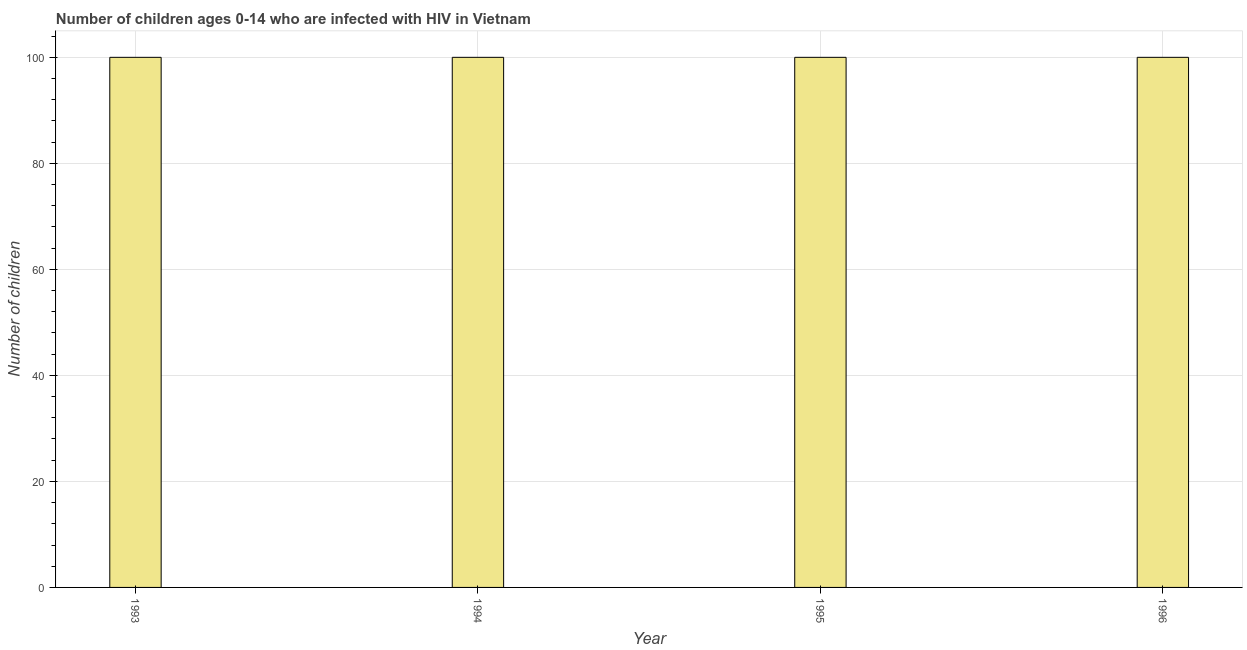Does the graph contain any zero values?
Provide a succinct answer. No. Does the graph contain grids?
Your answer should be compact. Yes. What is the title of the graph?
Make the answer very short. Number of children ages 0-14 who are infected with HIV in Vietnam. What is the label or title of the Y-axis?
Your answer should be compact. Number of children. What is the sum of the number of children living with hiv?
Your answer should be very brief. 400. What is the average number of children living with hiv per year?
Give a very brief answer. 100. What is the median number of children living with hiv?
Ensure brevity in your answer.  100. In how many years, is the number of children living with hiv greater than 100 ?
Provide a succinct answer. 0. What is the ratio of the number of children living with hiv in 1994 to that in 1996?
Ensure brevity in your answer.  1. Is the difference between the number of children living with hiv in 1993 and 1996 greater than the difference between any two years?
Offer a terse response. Yes. What is the difference between the highest and the second highest number of children living with hiv?
Make the answer very short. 0. Is the sum of the number of children living with hiv in 1993 and 1996 greater than the maximum number of children living with hiv across all years?
Provide a succinct answer. Yes. What is the difference between the highest and the lowest number of children living with hiv?
Keep it short and to the point. 0. How many bars are there?
Make the answer very short. 4. Are all the bars in the graph horizontal?
Your response must be concise. No. What is the Number of children in 1993?
Your answer should be very brief. 100. What is the Number of children of 1995?
Make the answer very short. 100. What is the difference between the Number of children in 1993 and 1994?
Your response must be concise. 0. What is the difference between the Number of children in 1993 and 1995?
Offer a terse response. 0. What is the difference between the Number of children in 1993 and 1996?
Make the answer very short. 0. What is the difference between the Number of children in 1994 and 1995?
Offer a very short reply. 0. What is the ratio of the Number of children in 1993 to that in 1995?
Make the answer very short. 1. What is the ratio of the Number of children in 1993 to that in 1996?
Your answer should be very brief. 1. What is the ratio of the Number of children in 1994 to that in 1996?
Provide a short and direct response. 1. 